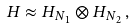<formula> <loc_0><loc_0><loc_500><loc_500>H \approx H _ { N _ { 1 } } \otimes H _ { N _ { 2 } } \, ,</formula> 